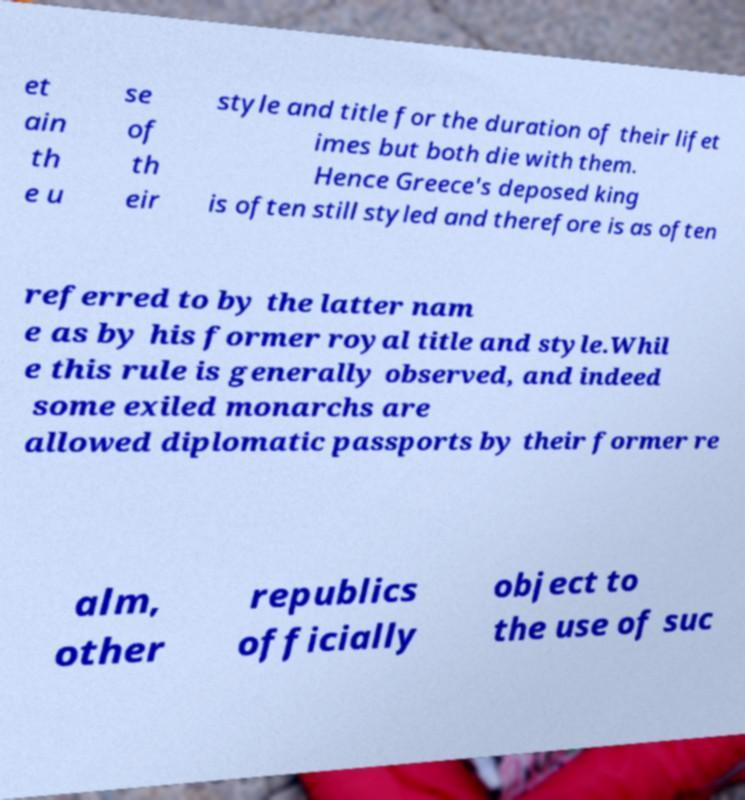Please identify and transcribe the text found in this image. et ain th e u se of th eir style and title for the duration of their lifet imes but both die with them. Hence Greece's deposed king is often still styled and therefore is as often referred to by the latter nam e as by his former royal title and style.Whil e this rule is generally observed, and indeed some exiled monarchs are allowed diplomatic passports by their former re alm, other republics officially object to the use of suc 